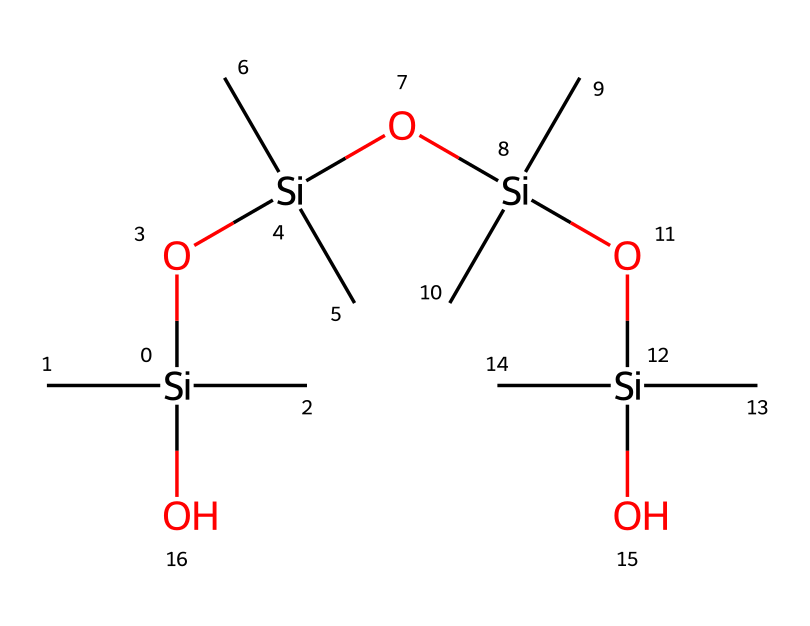what is the main element in this compound? The chemical structure reveals numerous silicon (Si) atoms at its core, indicating that silicon is the primary element.
Answer: silicon how many silicon atoms are present? By examining the SMILES representation, there are four occurrences of silicon atoms denoted by the notation 'Si'.
Answer: four what is the functional group in this compound? The presence of the 'O' between the silicon atoms signifies the siloxane functional group (-Si-O-).
Answer: siloxane what is the total number of oxygen atoms? Counting the oxygen atoms in the provided structure, we find there are four oxygen atoms associated with the siloxane linkages.
Answer: four why is this compound used for waterproofing? The siloxane functional groups impart hydrophobic properties, making the compound effective in repelling water and protecting surfaces.
Answer: hydrophobic properties what role do the carbon atoms play in this compound? The carbon (C) atoms are typically used to enhance the flexibility and compatibility of the organosilicon compound, contributing to its overall performance.
Answer: flexibility how does the structure contribute to moisture resistance? The repetitive siloxane units create a barrier that inhibits moisture penetration, thereby increasing resistance to water.
Answer: barrier formation 